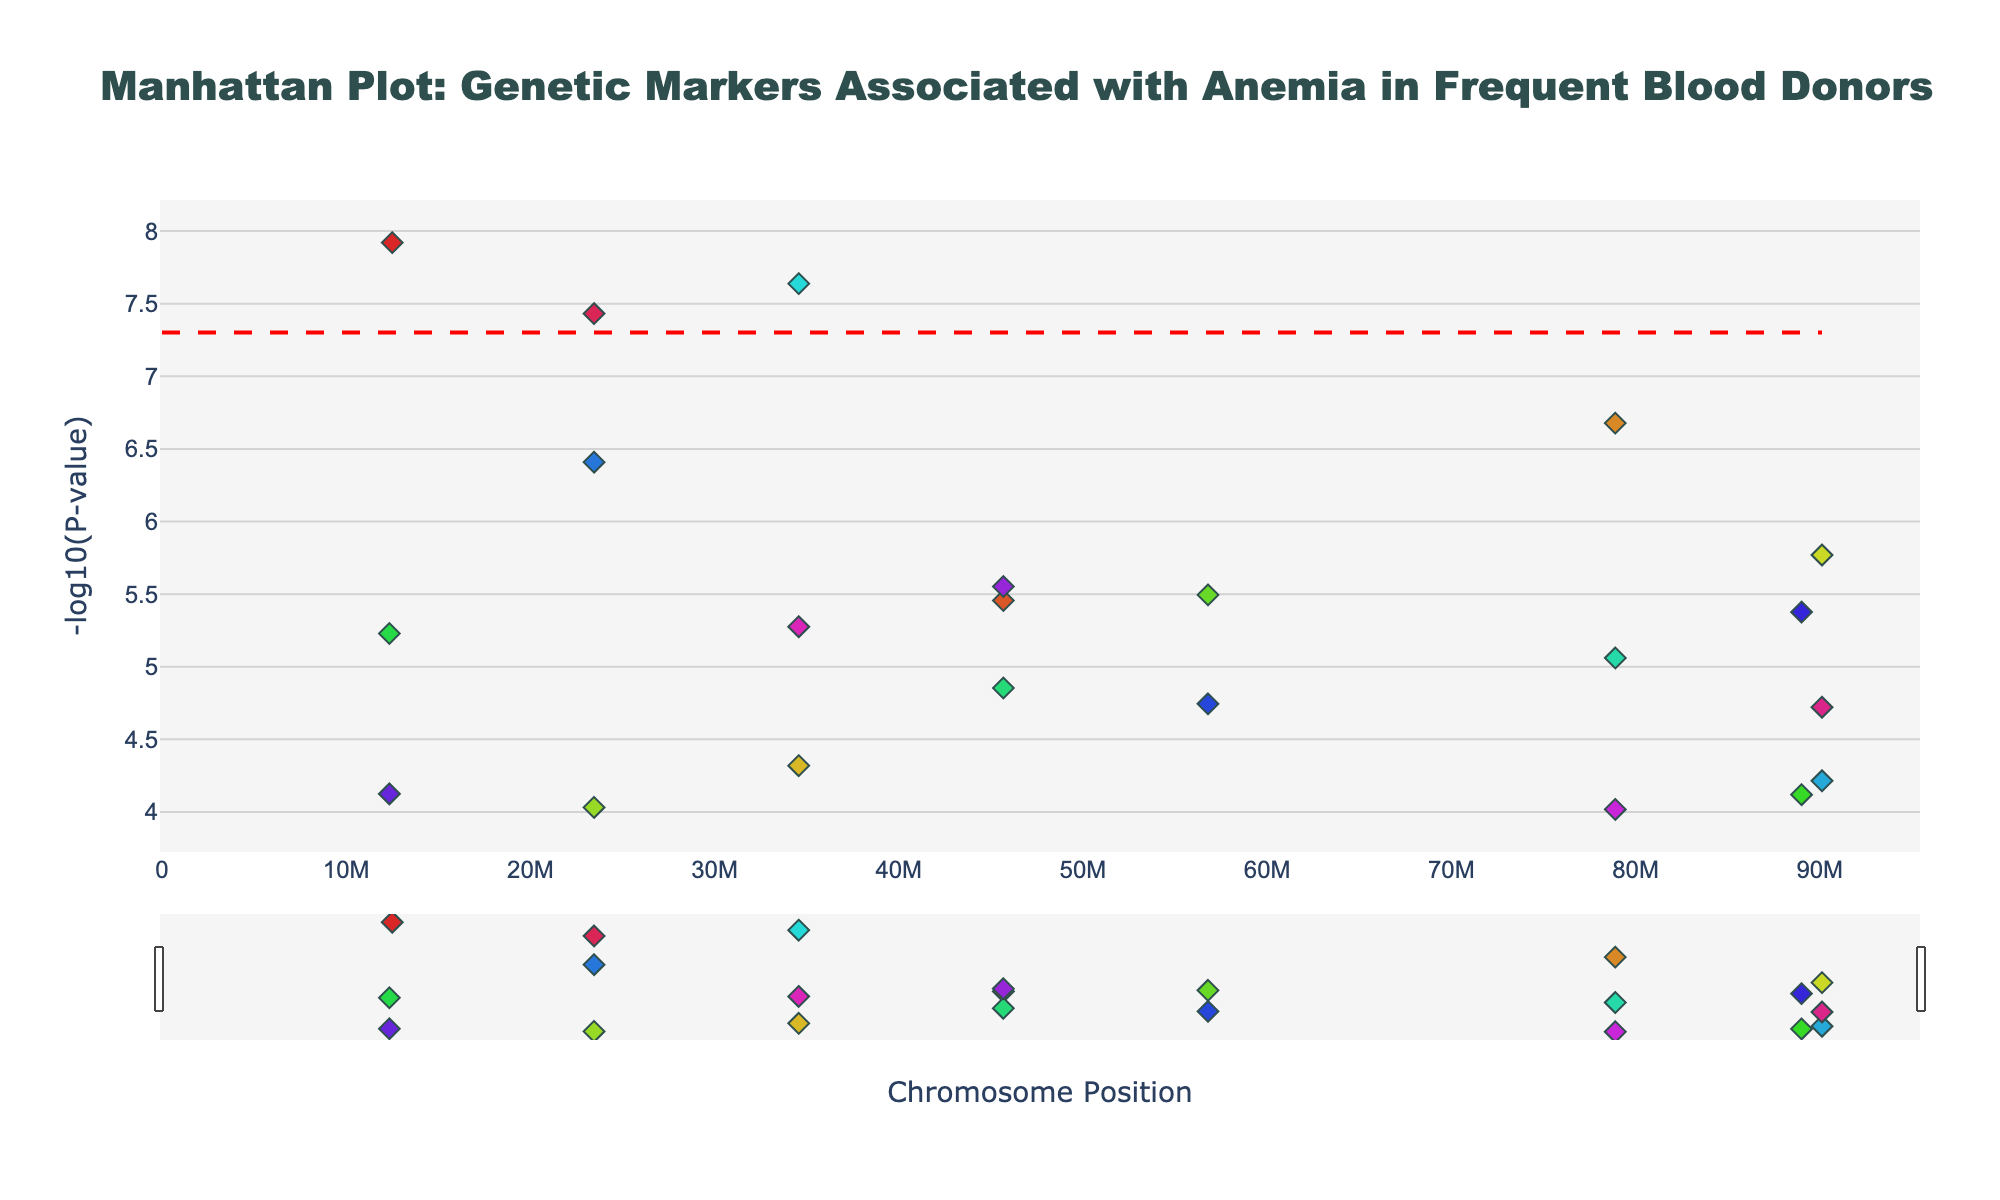What is the title of the plot? The title of the plot is displayed at the top and reads, "Manhattan Plot: Genetic Markers Associated with Anemia in Frequent Blood Donors."
Answer: Manhattan Plot: Genetic Markers Associated with Anemia in Frequent Blood Donors What does the x-axis represent? The x-axis represents the chromosome positions, ranging across various chromosomes from 1 to 22, as indicated by the labels in relation to their positions.
Answer: Chromosome Position What is the y-axis showing? The y-axis shows the -log10 of the P-values, which indicates the significance of each genetic marker.
Answer: -log10(P-value) How many chromosomes have significant markers below the threshold line? The significant threshold line is drawn at -log10(P-value) of approximately 7.3. The chromosomes with markers below this line (higher significance) are Chromosome 1 (rs1800562), Chromosome 12 (another rs1800562), and Chromosome 22 (yet another rs1800562).
Answer: 3 chromosomes Which SNP has the highest significance in Chromosome 1? By examining the markers within Chromosome 1, the SNP rs1800562 is plotted lowest on the y-axis, indicating the highest significance.
Answer: rs1800562 What is the P-value for SNP rs855791 on Chromosome 3? The hover information on the Manhattan Plot would show the P-value when hovering over SNP rs855791 on Chromosome 3. According to the data, the P-value for SNP rs855791 in Chromosome 3 is 2.1e-7.
Answer: 2.1e-7 Compare the significance of SNP rs3811647 on Chromosome 5 and Chromosome 16. Which is more significant? The y-axis value for -log10(P-value) of SNP rs3811647 is higher on Chromosome 5 than on Chromosome 16, indicating a lower P-value and higher significance on Chromosome 5.
Answer: Chromosome 5 What colors are used to represent the chromosomes? Each chromosome is represented by a different color. For example, Chromosome 1 is an HSL color (calculated as approximately 0 degrees on the HSL color wheel), and successive chromosomes follow in increments. The colors vary distinctly for each chromosome number.
Answer: Different colors for each chromosome Identify the SNP with the lowest P-value in the dataset. The SNP with the lowest P-value will be plotted at the highest -log10(P-value). The data indicates that SNP rs1800562 in Chromosome 1, Chromosome 12, and Chromosome 22 has the lowest P-value at 1.2e-8, 2.3e-8, and 3.7e-8, respectively. The lowest overall is rs1800562 with 1.2e-8.
Answer: rs1800562 